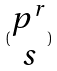<formula> <loc_0><loc_0><loc_500><loc_500>( \begin{matrix} p ^ { r } \\ s \end{matrix} )</formula> 